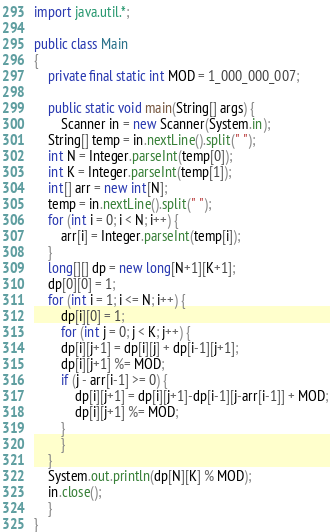Convert code to text. <code><loc_0><loc_0><loc_500><loc_500><_Java_>import java.util.*;
 
public class Main
{
    private final static int MOD = 1_000_000_007;
 
    public static void main(String[] args) {
        Scanner in = new Scanner(System.in);
	String[] temp = in.nextLine().split(" ");
	int N = Integer.parseInt(temp[0]);
	int K = Integer.parseInt(temp[1]);
	int[] arr = new int[N];
	temp = in.nextLine().split(" ");
	for (int i = 0; i < N; i++) {
	    arr[i] = Integer.parseInt(temp[i]);
	}
	long[][] dp = new long[N+1][K+1];
	dp[0][0] = 1;
	for (int i = 1; i <= N; i++) {
	    dp[i][0] = 1;
	    for (int j = 0; j < K; j++) {
		dp[i][j+1] = dp[i][j] + dp[i-1][j+1];
		dp[i][j+1] %= MOD;
		if (j - arr[i-1] >= 0) {
		    dp[i][j+1] = dp[i][j+1]-dp[i-1][j-arr[i-1]] + MOD;
		    dp[i][j+1] %= MOD;
		}
	    }
	}
	System.out.println(dp[N][K] % MOD);
	in.close();
    }
}
</code> 